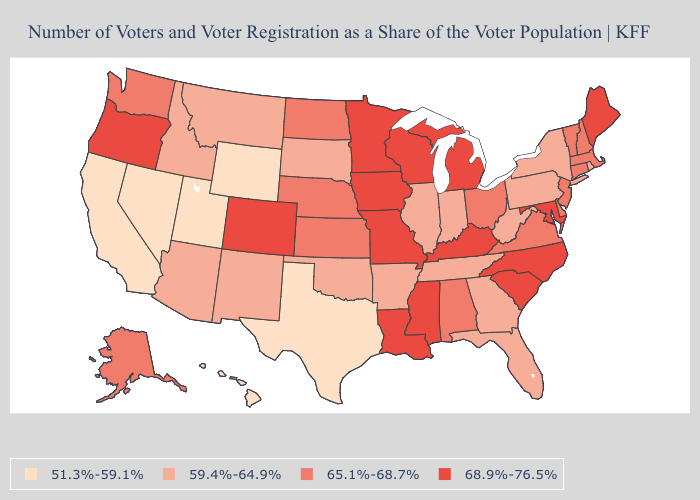Which states have the lowest value in the South?
Concise answer only. Texas. What is the value of Kansas?
Answer briefly. 65.1%-68.7%. Does the first symbol in the legend represent the smallest category?
Keep it brief. Yes. What is the value of Montana?
Be succinct. 59.4%-64.9%. What is the lowest value in the USA?
Write a very short answer. 51.3%-59.1%. Does California have the lowest value in the West?
Short answer required. Yes. Which states have the highest value in the USA?
Quick response, please. Colorado, Iowa, Kentucky, Louisiana, Maine, Maryland, Michigan, Minnesota, Mississippi, Missouri, North Carolina, Oregon, South Carolina, Wisconsin. How many symbols are there in the legend?
Write a very short answer. 4. What is the value of Alaska?
Give a very brief answer. 65.1%-68.7%. What is the highest value in the West ?
Write a very short answer. 68.9%-76.5%. Does Minnesota have the same value as Maryland?
Short answer required. Yes. Name the states that have a value in the range 59.4%-64.9%?
Be succinct. Arizona, Arkansas, Florida, Georgia, Idaho, Illinois, Indiana, Montana, New Mexico, New York, Oklahoma, Pennsylvania, Rhode Island, South Dakota, Tennessee, West Virginia. Among the states that border South Dakota , does Wyoming have the lowest value?
Give a very brief answer. Yes. Name the states that have a value in the range 59.4%-64.9%?
Write a very short answer. Arizona, Arkansas, Florida, Georgia, Idaho, Illinois, Indiana, Montana, New Mexico, New York, Oklahoma, Pennsylvania, Rhode Island, South Dakota, Tennessee, West Virginia. Does Rhode Island have a lower value than Arizona?
Quick response, please. No. 